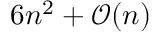Convert formula to latex. <formula><loc_0><loc_0><loc_500><loc_500>6 n ^ { 2 } + { \mathcal { O } } ( n )</formula> 